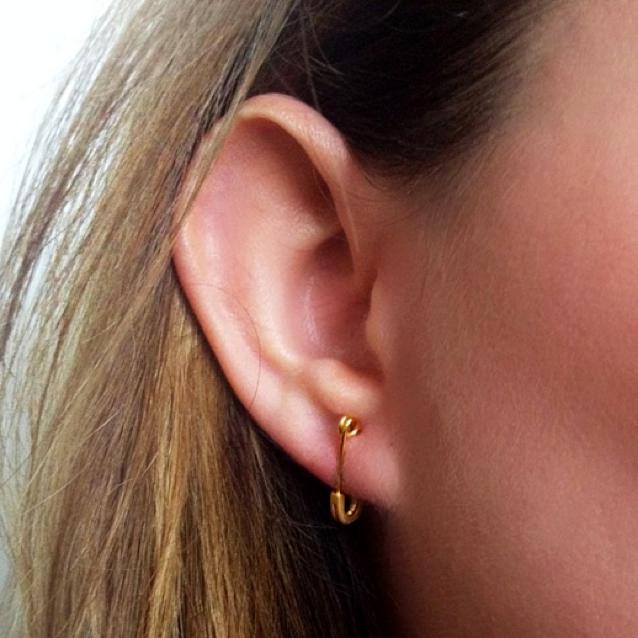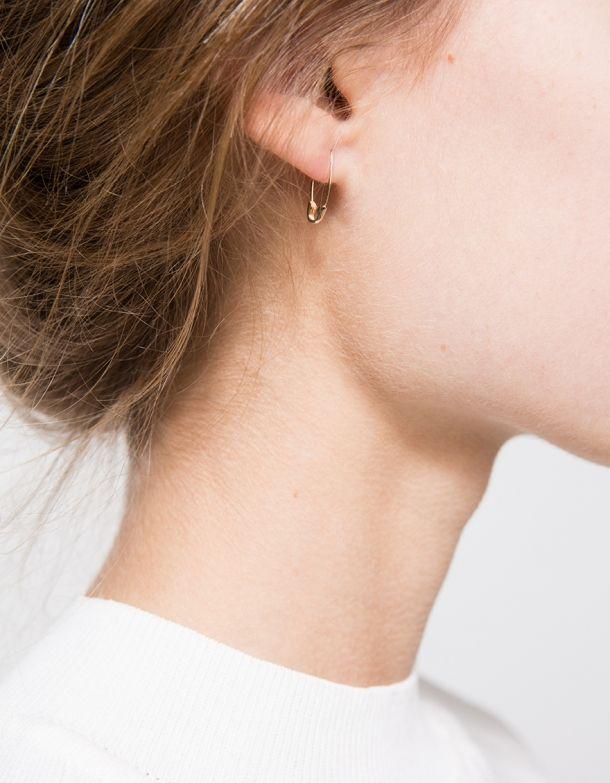The first image is the image on the left, the second image is the image on the right. Examine the images to the left and right. Is the description "In each image, a woman with blonde hair is shown from the side with a small safety pin, clasp end pointed down, being used as a earring." accurate? Answer yes or no. Yes. The first image is the image on the left, the second image is the image on the right. Evaluate the accuracy of this statement regarding the images: "There is a woman wearing a safety pin earring in each image.". Is it true? Answer yes or no. Yes. 